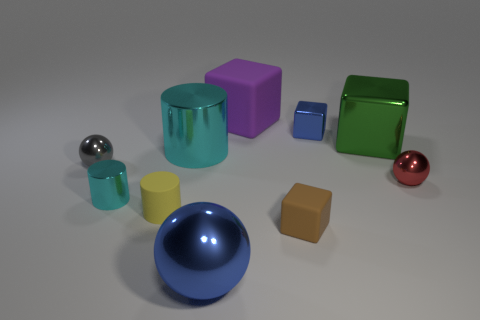Subtract 1 blocks. How many blocks are left? 3 Subtract all spheres. How many objects are left? 7 Add 3 big balls. How many big balls are left? 4 Add 9 small red metal things. How many small red metal things exist? 10 Subtract 1 green blocks. How many objects are left? 9 Subtract all shiny cylinders. Subtract all tiny brown matte objects. How many objects are left? 7 